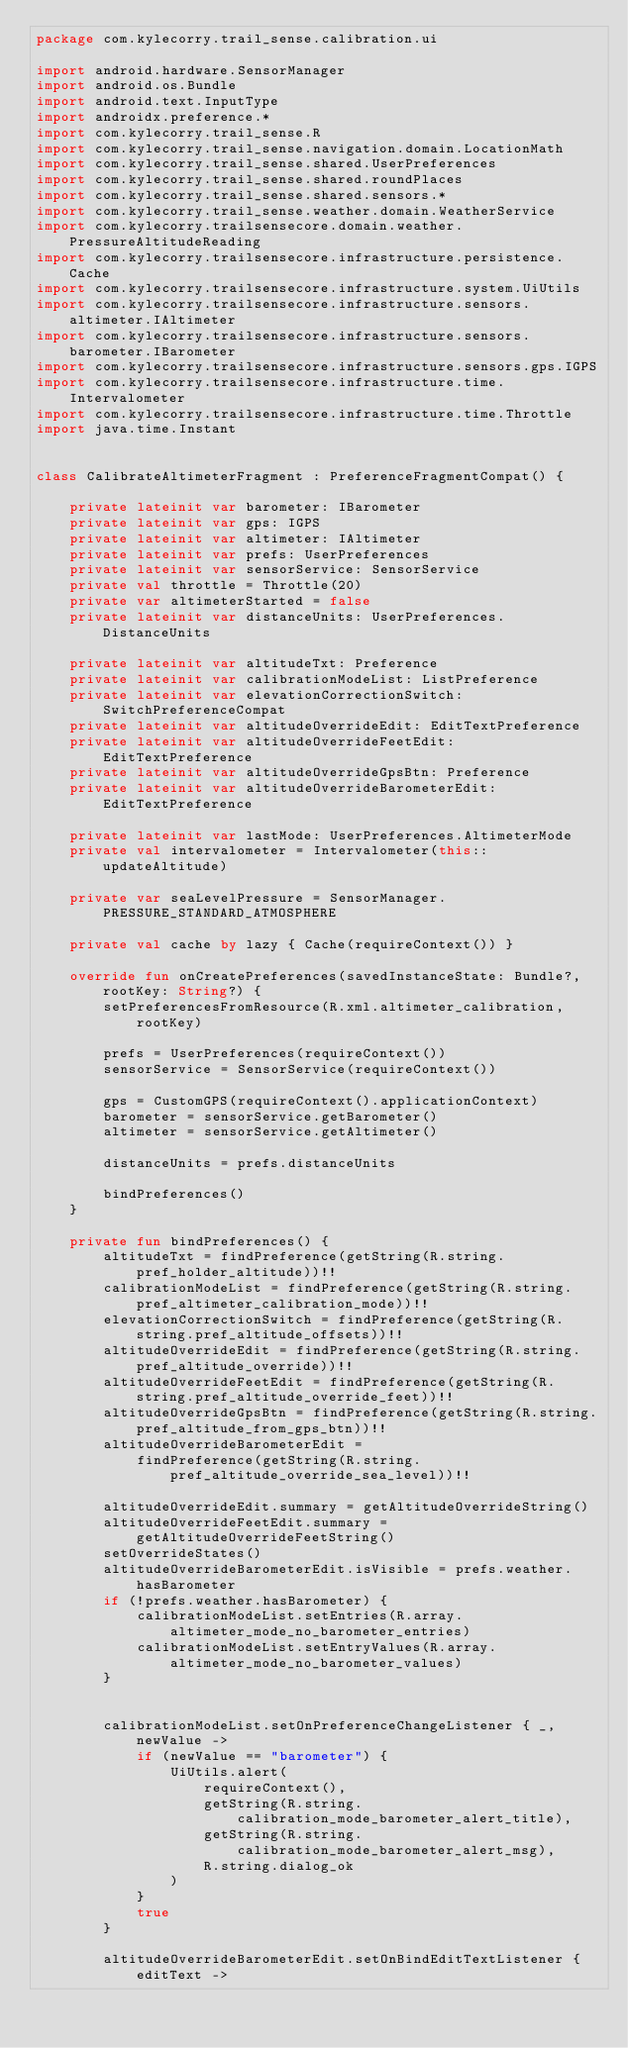Convert code to text. <code><loc_0><loc_0><loc_500><loc_500><_Kotlin_>package com.kylecorry.trail_sense.calibration.ui

import android.hardware.SensorManager
import android.os.Bundle
import android.text.InputType
import androidx.preference.*
import com.kylecorry.trail_sense.R
import com.kylecorry.trail_sense.navigation.domain.LocationMath
import com.kylecorry.trail_sense.shared.UserPreferences
import com.kylecorry.trail_sense.shared.roundPlaces
import com.kylecorry.trail_sense.shared.sensors.*
import com.kylecorry.trail_sense.weather.domain.WeatherService
import com.kylecorry.trailsensecore.domain.weather.PressureAltitudeReading
import com.kylecorry.trailsensecore.infrastructure.persistence.Cache
import com.kylecorry.trailsensecore.infrastructure.system.UiUtils
import com.kylecorry.trailsensecore.infrastructure.sensors.altimeter.IAltimeter
import com.kylecorry.trailsensecore.infrastructure.sensors.barometer.IBarometer
import com.kylecorry.trailsensecore.infrastructure.sensors.gps.IGPS
import com.kylecorry.trailsensecore.infrastructure.time.Intervalometer
import com.kylecorry.trailsensecore.infrastructure.time.Throttle
import java.time.Instant


class CalibrateAltimeterFragment : PreferenceFragmentCompat() {

    private lateinit var barometer: IBarometer
    private lateinit var gps: IGPS
    private lateinit var altimeter: IAltimeter
    private lateinit var prefs: UserPreferences
    private lateinit var sensorService: SensorService
    private val throttle = Throttle(20)
    private var altimeterStarted = false
    private lateinit var distanceUnits: UserPreferences.DistanceUnits

    private lateinit var altitudeTxt: Preference
    private lateinit var calibrationModeList: ListPreference
    private lateinit var elevationCorrectionSwitch: SwitchPreferenceCompat
    private lateinit var altitudeOverrideEdit: EditTextPreference
    private lateinit var altitudeOverrideFeetEdit: EditTextPreference
    private lateinit var altitudeOverrideGpsBtn: Preference
    private lateinit var altitudeOverrideBarometerEdit: EditTextPreference

    private lateinit var lastMode: UserPreferences.AltimeterMode
    private val intervalometer = Intervalometer(this::updateAltitude)

    private var seaLevelPressure = SensorManager.PRESSURE_STANDARD_ATMOSPHERE

    private val cache by lazy { Cache(requireContext()) }

    override fun onCreatePreferences(savedInstanceState: Bundle?, rootKey: String?) {
        setPreferencesFromResource(R.xml.altimeter_calibration, rootKey)

        prefs = UserPreferences(requireContext())
        sensorService = SensorService(requireContext())

        gps = CustomGPS(requireContext().applicationContext)
        barometer = sensorService.getBarometer()
        altimeter = sensorService.getAltimeter()

        distanceUnits = prefs.distanceUnits

        bindPreferences()
    }

    private fun bindPreferences() {
        altitudeTxt = findPreference(getString(R.string.pref_holder_altitude))!!
        calibrationModeList = findPreference(getString(R.string.pref_altimeter_calibration_mode))!!
        elevationCorrectionSwitch = findPreference(getString(R.string.pref_altitude_offsets))!!
        altitudeOverrideEdit = findPreference(getString(R.string.pref_altitude_override))!!
        altitudeOverrideFeetEdit = findPreference(getString(R.string.pref_altitude_override_feet))!!
        altitudeOverrideGpsBtn = findPreference(getString(R.string.pref_altitude_from_gps_btn))!!
        altitudeOverrideBarometerEdit =
            findPreference(getString(R.string.pref_altitude_override_sea_level))!!

        altitudeOverrideEdit.summary = getAltitudeOverrideString()
        altitudeOverrideFeetEdit.summary = getAltitudeOverrideFeetString()
        setOverrideStates()
        altitudeOverrideBarometerEdit.isVisible = prefs.weather.hasBarometer
        if (!prefs.weather.hasBarometer) {
            calibrationModeList.setEntries(R.array.altimeter_mode_no_barometer_entries)
            calibrationModeList.setEntryValues(R.array.altimeter_mode_no_barometer_values)
        }


        calibrationModeList.setOnPreferenceChangeListener { _, newValue ->
            if (newValue == "barometer") {
                UiUtils.alert(
                    requireContext(),
                    getString(R.string.calibration_mode_barometer_alert_title),
                    getString(R.string.calibration_mode_barometer_alert_msg),
                    R.string.dialog_ok
                )
            }
            true
        }

        altitudeOverrideBarometerEdit.setOnBindEditTextListener { editText -></code> 